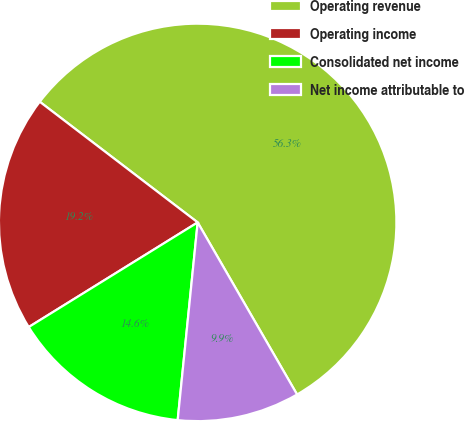Convert chart. <chart><loc_0><loc_0><loc_500><loc_500><pie_chart><fcel>Operating revenue<fcel>Operating income<fcel>Consolidated net income<fcel>Net income attributable to<nl><fcel>56.28%<fcel>19.21%<fcel>14.57%<fcel>9.94%<nl></chart> 